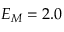<formula> <loc_0><loc_0><loc_500><loc_500>E _ { M } = 2 . 0</formula> 